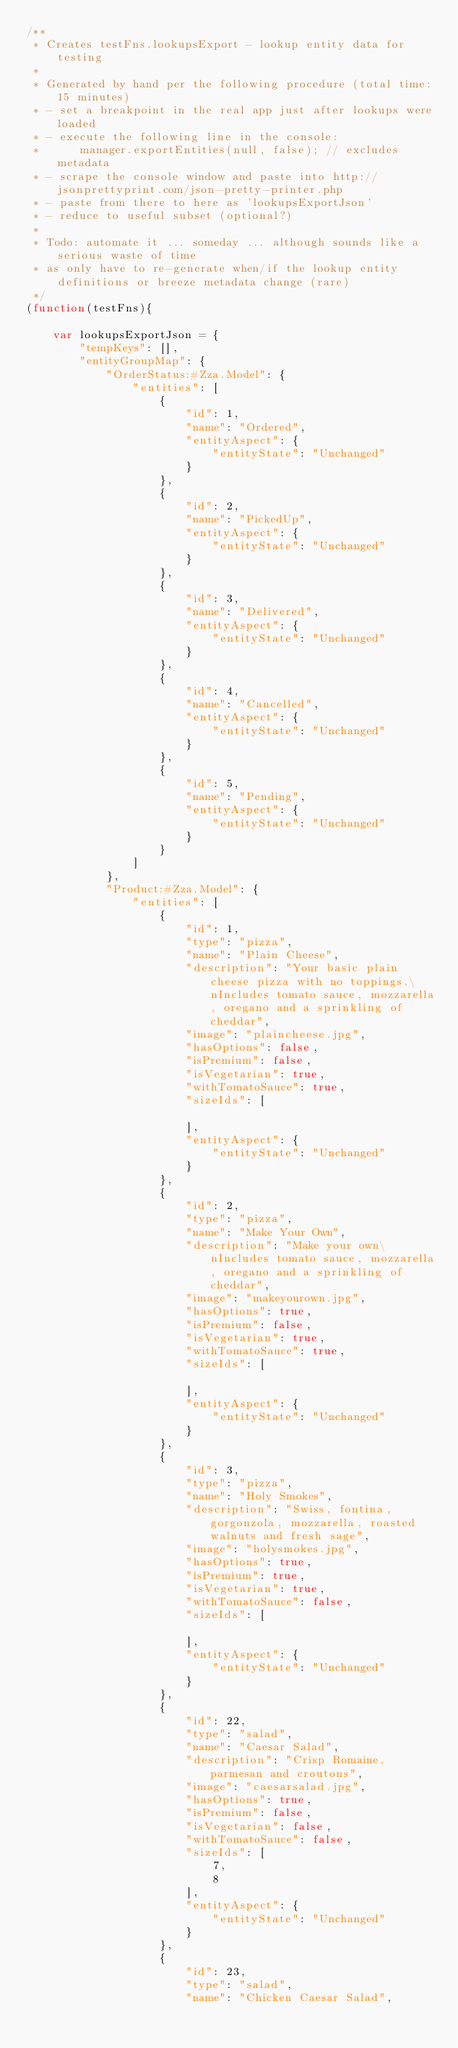<code> <loc_0><loc_0><loc_500><loc_500><_JavaScript_>/**
 * Creates testFns.lookupsExport - lookup entity data for testing
 *
 * Generated by hand per the following procedure (total time: 15 minutes)
 * - set a breakpoint in the real app just after lookups were loaded
 * - execute the following line in the console:
 *      manager.exportEntities(null, false); // excludes metadata
 * - scrape the console window and paste into http://jsonprettyprint.com/json-pretty-printer.php
 * - paste from there to here as 'lookupsExportJson'
 * - reduce to useful subset (optional?)
 *
 * Todo: automate it ... someday ... although sounds like a serious waste of time
 * as only have to re-generate when/if the lookup entity definitions or breeze metadata change (rare)
 */
(function(testFns){

    var lookupsExportJson = {
        "tempKeys": [],
        "entityGroupMap": {
            "OrderStatus:#Zza.Model": {
                "entities": [
                    {
                        "id": 1,
                        "name": "Ordered",
                        "entityAspect": {
                            "entityState": "Unchanged"
                        }
                    },
                    {
                        "id": 2,
                        "name": "PickedUp",
                        "entityAspect": {
                            "entityState": "Unchanged"
                        }
                    },
                    {
                        "id": 3,
                        "name": "Delivered",
                        "entityAspect": {
                            "entityState": "Unchanged"
                        }
                    },
                    {
                        "id": 4,
                        "name": "Cancelled",
                        "entityAspect": {
                            "entityState": "Unchanged"
                        }
                    },
                    {
                        "id": 5,
                        "name": "Pending",
                        "entityAspect": {
                            "entityState": "Unchanged"
                        }
                    }
                ]
            },
            "Product:#Zza.Model": {
                "entities": [
                    {
                        "id": 1,
                        "type": "pizza",
                        "name": "Plain Cheese",
                        "description": "Your basic plain cheese pizza with no toppings.\nIncludes tomato sauce, mozzarella, oregano and a sprinkling of cheddar",
                        "image": "plaincheese.jpg",
                        "hasOptions": false,
                        "isPremium": false,
                        "isVegetarian": true,
                        "withTomatoSauce": true,
                        "sizeIds": [

                        ],
                        "entityAspect": {
                            "entityState": "Unchanged"
                        }
                    },
                    {
                        "id": 2,
                        "type": "pizza",
                        "name": "Make Your Own",
                        "description": "Make your own\nIncludes tomato sauce, mozzarella, oregano and a sprinkling of cheddar",
                        "image": "makeyourown.jpg",
                        "hasOptions": true,
                        "isPremium": false,
                        "isVegetarian": true,
                        "withTomatoSauce": true,
                        "sizeIds": [

                        ],
                        "entityAspect": {
                            "entityState": "Unchanged"
                        }
                    },
                    {
                        "id": 3,
                        "type": "pizza",
                        "name": "Holy Smokes",
                        "description": "Swiss, fontina, gorgonzola, mozzarella, roasted walnuts and fresh sage",
                        "image": "holysmokes.jpg",
                        "hasOptions": true,
                        "isPremium": true,
                        "isVegetarian": true,
                        "withTomatoSauce": false,
                        "sizeIds": [

                        ],
                        "entityAspect": {
                            "entityState": "Unchanged"
                        }
                    },
                    {
                        "id": 22,
                        "type": "salad",
                        "name": "Caesar Salad",
                        "description": "Crisp Romaine, parmesan and croutons",
                        "image": "caesarsalad.jpg",
                        "hasOptions": true,
                        "isPremium": false,
                        "isVegetarian": false,
                        "withTomatoSauce": false,
                        "sizeIds": [
                            7,
                            8
                        ],
                        "entityAspect": {
                            "entityState": "Unchanged"
                        }
                    },
                    {
                        "id": 23,
                        "type": "salad",
                        "name": "Chicken Caesar Salad",</code> 